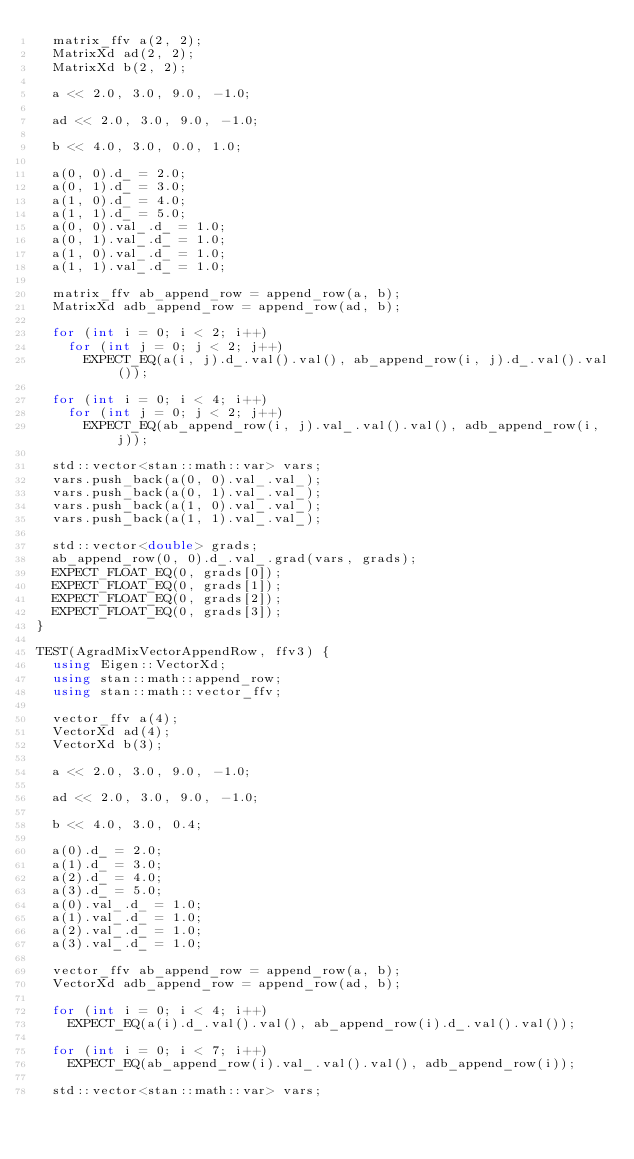Convert code to text. <code><loc_0><loc_0><loc_500><loc_500><_C++_>  matrix_ffv a(2, 2);
  MatrixXd ad(2, 2);
  MatrixXd b(2, 2);

  a << 2.0, 3.0, 9.0, -1.0;

  ad << 2.0, 3.0, 9.0, -1.0;

  b << 4.0, 3.0, 0.0, 1.0;

  a(0, 0).d_ = 2.0;
  a(0, 1).d_ = 3.0;
  a(1, 0).d_ = 4.0;
  a(1, 1).d_ = 5.0;
  a(0, 0).val_.d_ = 1.0;
  a(0, 1).val_.d_ = 1.0;
  a(1, 0).val_.d_ = 1.0;
  a(1, 1).val_.d_ = 1.0;

  matrix_ffv ab_append_row = append_row(a, b);
  MatrixXd adb_append_row = append_row(ad, b);

  for (int i = 0; i < 2; i++)
    for (int j = 0; j < 2; j++)
      EXPECT_EQ(a(i, j).d_.val().val(), ab_append_row(i, j).d_.val().val());

  for (int i = 0; i < 4; i++)
    for (int j = 0; j < 2; j++)
      EXPECT_EQ(ab_append_row(i, j).val_.val().val(), adb_append_row(i, j));

  std::vector<stan::math::var> vars;
  vars.push_back(a(0, 0).val_.val_);
  vars.push_back(a(0, 1).val_.val_);
  vars.push_back(a(1, 0).val_.val_);
  vars.push_back(a(1, 1).val_.val_);

  std::vector<double> grads;
  ab_append_row(0, 0).d_.val_.grad(vars, grads);
  EXPECT_FLOAT_EQ(0, grads[0]);
  EXPECT_FLOAT_EQ(0, grads[1]);
  EXPECT_FLOAT_EQ(0, grads[2]);
  EXPECT_FLOAT_EQ(0, grads[3]);
}

TEST(AgradMixVectorAppendRow, ffv3) {
  using Eigen::VectorXd;
  using stan::math::append_row;
  using stan::math::vector_ffv;

  vector_ffv a(4);
  VectorXd ad(4);
  VectorXd b(3);

  a << 2.0, 3.0, 9.0, -1.0;

  ad << 2.0, 3.0, 9.0, -1.0;

  b << 4.0, 3.0, 0.4;

  a(0).d_ = 2.0;
  a(1).d_ = 3.0;
  a(2).d_ = 4.0;
  a(3).d_ = 5.0;
  a(0).val_.d_ = 1.0;
  a(1).val_.d_ = 1.0;
  a(2).val_.d_ = 1.0;
  a(3).val_.d_ = 1.0;

  vector_ffv ab_append_row = append_row(a, b);
  VectorXd adb_append_row = append_row(ad, b);

  for (int i = 0; i < 4; i++)
    EXPECT_EQ(a(i).d_.val().val(), ab_append_row(i).d_.val().val());

  for (int i = 0; i < 7; i++)
    EXPECT_EQ(ab_append_row(i).val_.val().val(), adb_append_row(i));

  std::vector<stan::math::var> vars;</code> 